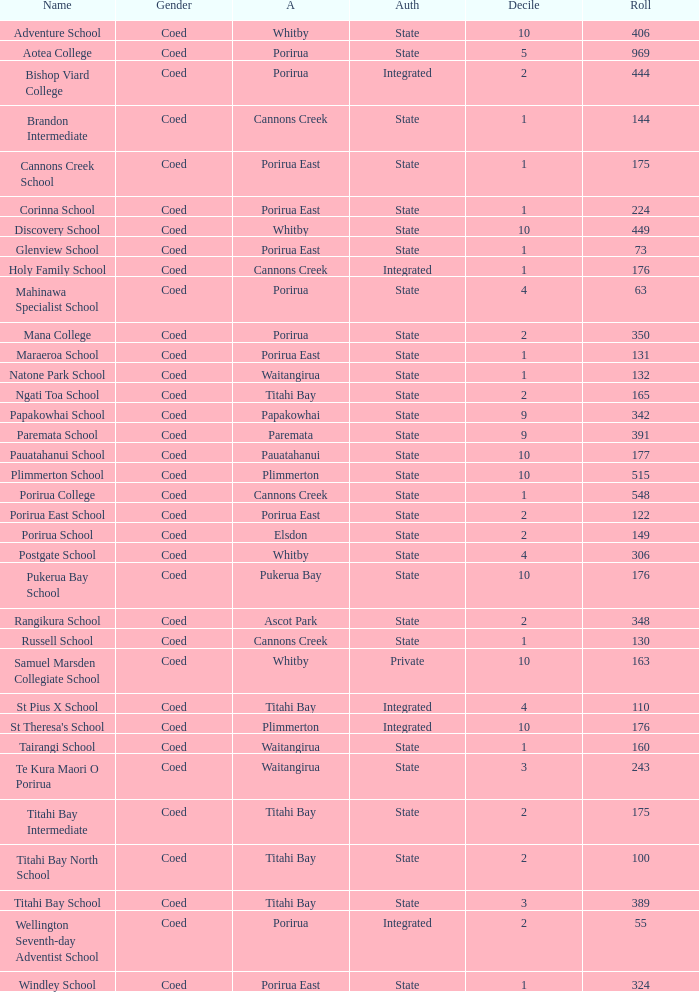What was the decile of Samuel Marsden Collegiate School in Whitby, when it had a roll higher than 163? 0.0. 